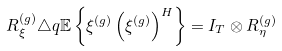Convert formula to latex. <formula><loc_0><loc_0><loc_500><loc_500>R ^ { ( g ) } _ { \xi } \triangle q \mathbb { E } \left \{ \xi ^ { ( g ) } \left ( \xi ^ { ( g ) } \right ) ^ { H } \right \} = I _ { T } \otimes R ^ { ( g ) } _ { \eta }</formula> 